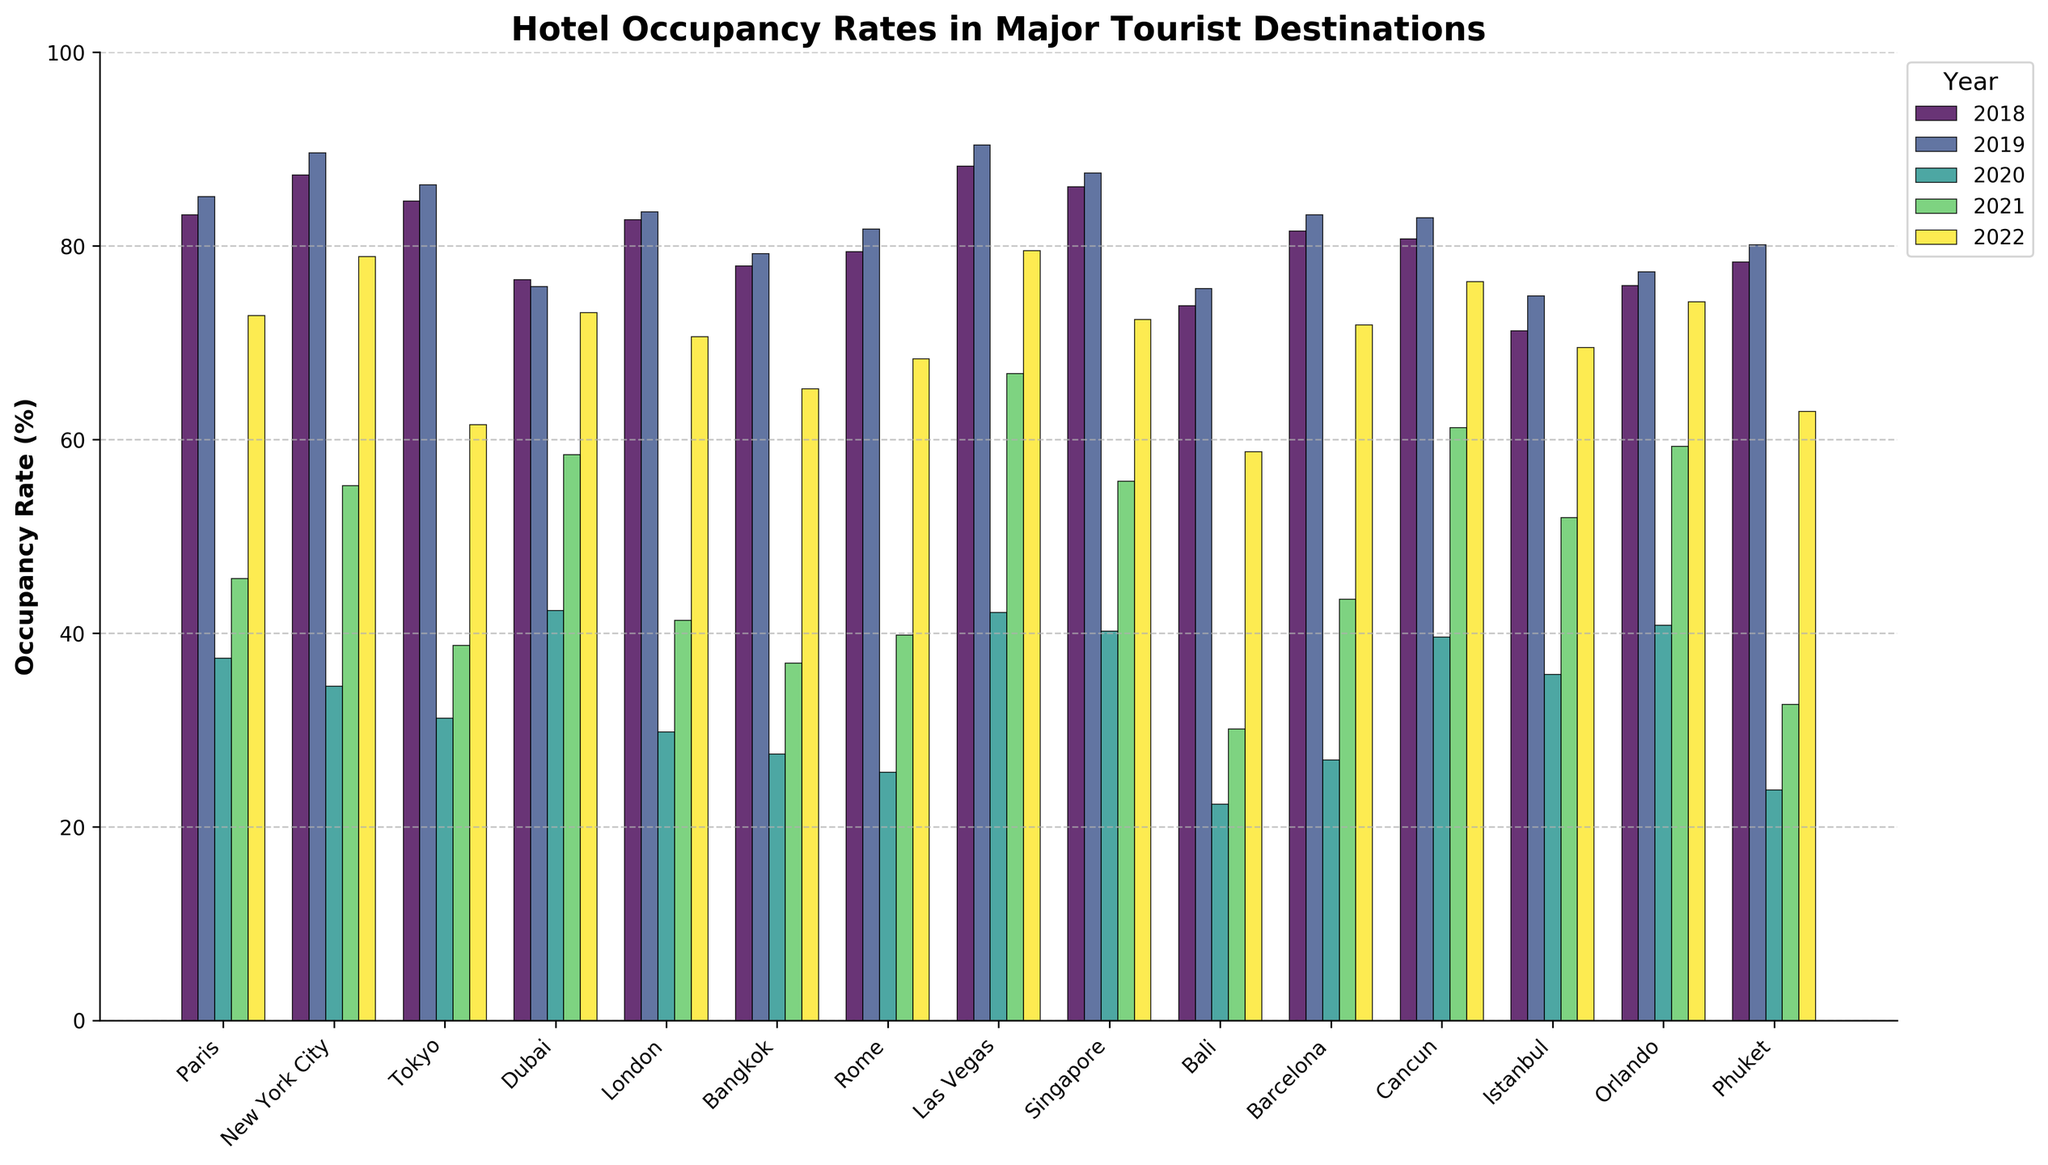What was the hotel occupancy rate trend in New York City from 2018 to 2022? To identify the trend, observe New York City’s bar heights for each year in the figure. The occupancy rate for 2020 drops significantly compared to 2019 and partially recovers in 2021 and 2022.
Answer: Decreased, then increased Which destination had the highest average occupancy rate across the 5 years, and what was the average? Calculate the average occupancy rate for each destination over 5 years. Paris had the highest, averaging \( (83.2 + 85.1 + 37.4 + 45.6 + 72.8) / 5 \).
Answer: Paris, 64.82 In which year did Las Vegas have its highest occupancy rate? Look at the bar heights for Las Vegas in the figure and note the year with the tallest bar. The year with the highest bar is 2019.
Answer: 2019 By how much did Bali’s occupancy rate change from 2020 to 2021 and then from 2021 to 2022? For each period, subtract the earlier year’s rate from the later year’s rate: 2021 - 2020 and 2022 - 2021. For 2020 to 2021: 30.1 - 22.3 = 7.8. For 2021 to 2022: 58.7 - 30.1 = 28.6.
Answer: 7.8, 28.6 Which city had the lowest occupancy rate in 2020, and what was it? Identify the shortest bar for the year 2020. Bali had the lowest rate.
Answer: Bali, 22.3 What were the three highest occupancy rates in 2019, and which cities did they belong to? Find the tallest three bars in 2019 and identify the corresponding cities: Las Vegas, New York City, and Singapore.
Answer: Las Vegas 90.4, New York City 89.6, Singapore 87.5 Which city shows the most significant improvement in occupancy rates from 2020 to 2022? Calculate the difference between 2022 and 2020 occupancy rates for each city and find the largest change: Las Vegas with \( 79.5 - 42.1 = 37.4 \).
Answer: Las Vegas, 37.4 Explain the visual difference in occupancy rate trends among Paris, New York City, and Tokyo from 2018 to 2022. Paris, New York City, and Tokyo had peak occupancy in 2019 followed by a sharp decline in 2020. New York City's rates bounce back more significantly than Tokyo's by 2022, while Paris experienced moderate recovery.
Answer: Paris and New York City: sharp rise then partial recovery; Tokyo: less recovery 